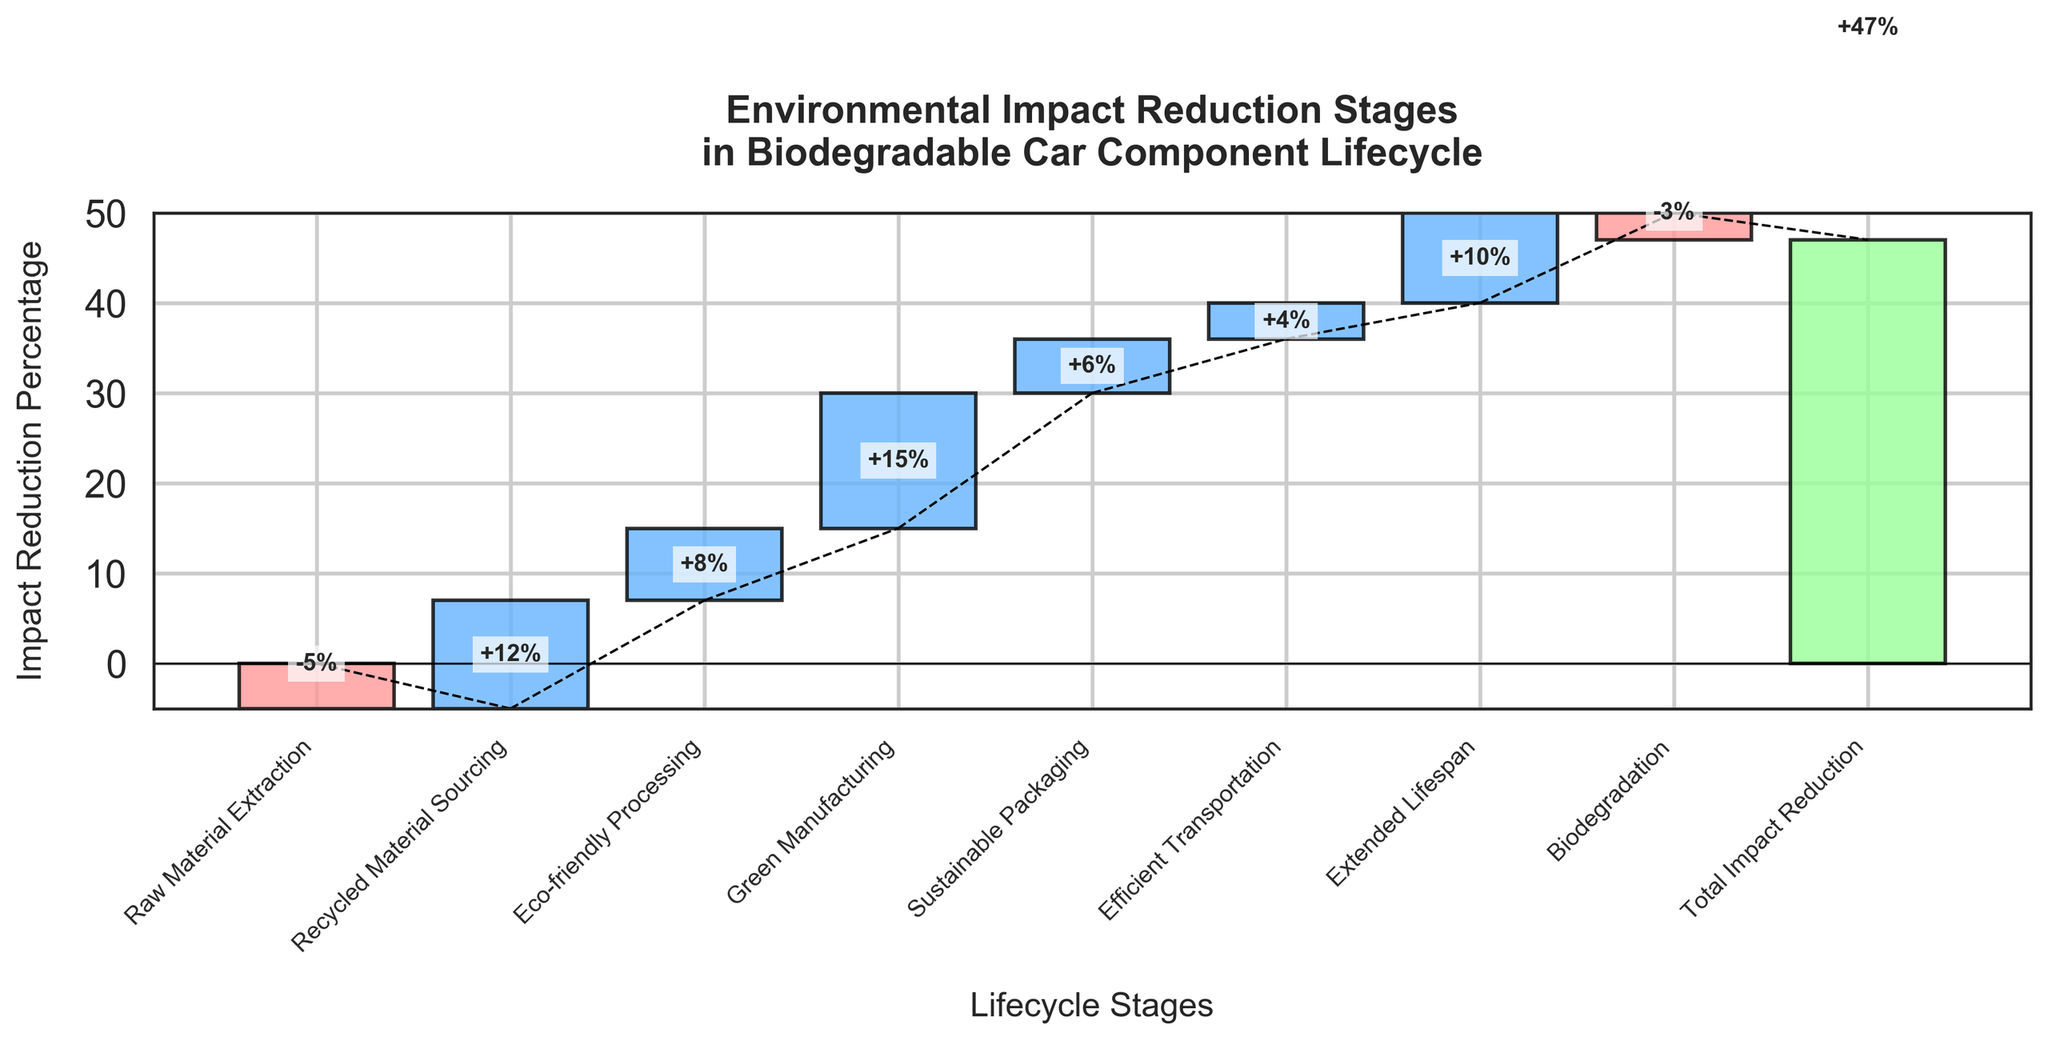What's the title of the chart? The title of the chart is located at the top of the figure, specifying the focus of the visualized data. The title reads "Environmental Impact Reduction Stages in Biodegradable Car Component Lifecycle".
Answer: Environmental Impact Reduction Stages in Biodegradable Car Component Lifecycle Which stage contributes the most to impact reduction? By observing the heights of the bars, the stage with the highest positive impact reduction can be identified. "Green Manufacturing" has the tallest bar indicating a 15% reduction.
Answer: Green Manufacturing How many stages show a negative impact reduction? By counting the bars with negative values (shown in a distinct color for easy identification), two stages—"Raw Material Extraction" and "Biodegradation"—show negative impact reductions of -5% and -3%, respectively.
Answer: 2 What is the total impact reduction after "Green Manufacturing"? To get the cumulative impact after "Green Manufacturing," we sum the values of all preceding stages, which is 12% (Recycled Material Sourcing) + 8% (Eco-friendly Processing) + 15% (Green Manufacturing), totaling 35%.
Answer: 35% By how much does the "Extended Lifespan" stage reduce the impact? The label on the bar for "Extended Lifespan" indicates its impact reduction directly, which is 10%.
Answer: 10% Which stages have lower impact reductions than "Eco-friendly Processing"? Comparing the stage values, "Eco-friendly Processing" has an 8% reduction. Stages with lower reductions are "Recycled Material Sourcing" (12%) and "Biodegradation" (-3%).
Answer: Recycled Material Sourcing, Biodegradation How much greater is the impact reduction in "Sustainable Packaging" compared to "Efficient Transportation"? The impact reductions are 6% for "Sustainable Packaging" and 4% for "Efficient Transportation." The difference is calculated as 6% - 4% = 2%.
Answer: 2% What is the net impact change from "Raw Material Extraction" to "Extended Lifespan"? The cumulative impact from "Raw Material Extraction" (-5%) to "Extended Lifespan" (10%) involves summing the values in sequence, i.e., -5 + 12 + 8 + 15 + 6 + 4 + 10 = 50%.
Answer: 50% What is the percentage reduction displayed by the last bar? The final bar (Total Impact Reduction) sums up all the stages' reductions, which totals to 47%.
Answer: 47% 